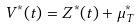Convert formula to latex. <formula><loc_0><loc_0><loc_500><loc_500>V ^ { * } ( t ) = Z ^ { * } ( t ) + \mu _ { T } ^ { * }</formula> 